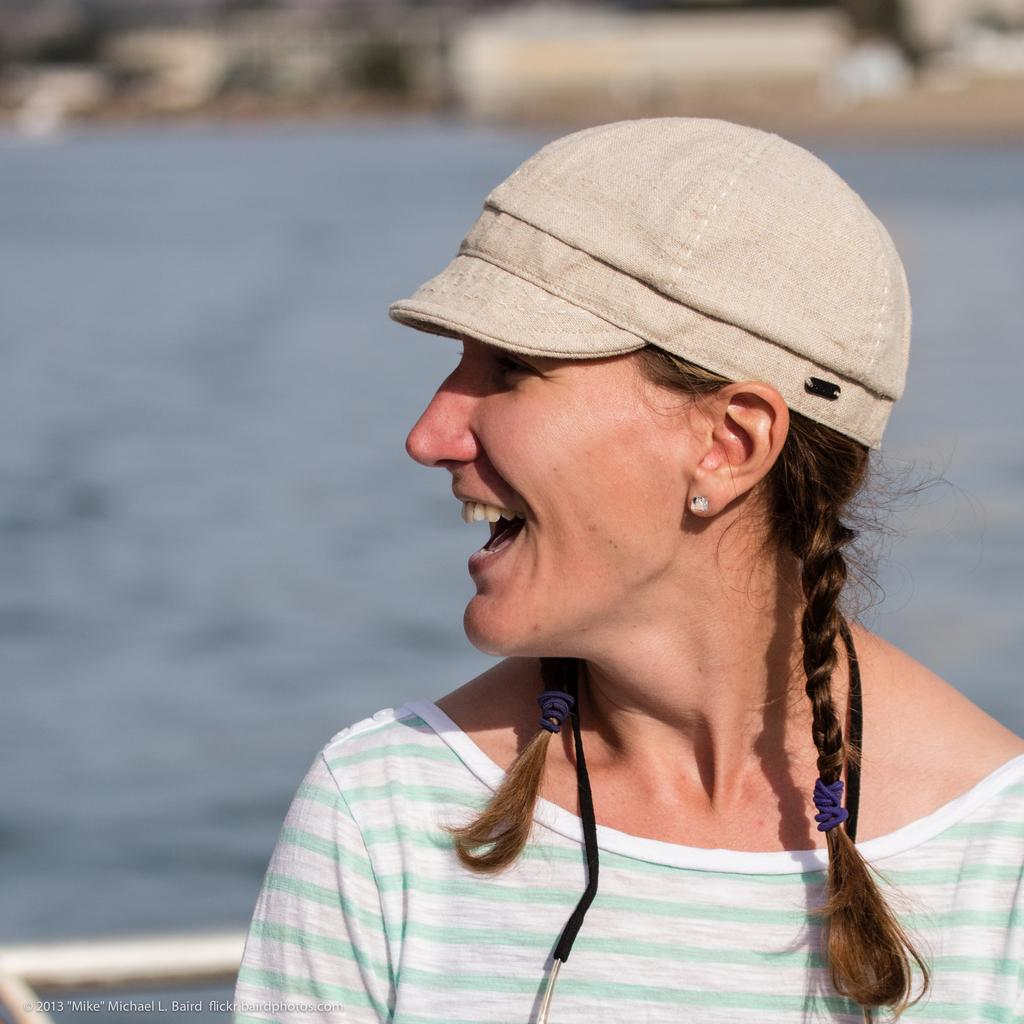What is present in the image? There is a woman in the image. Can you describe what the woman is wearing on her head? The woman is wearing a cap. What can be seen in the background of the image? There is water visible in the background of the image. What type of trees can be seen in the image? There are no trees present in the image. Was there an earthquake that caused the water to be visible in the image? There is no information about an earthquake in the image or the provided facts. 